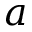<formula> <loc_0><loc_0><loc_500><loc_500>a</formula> 